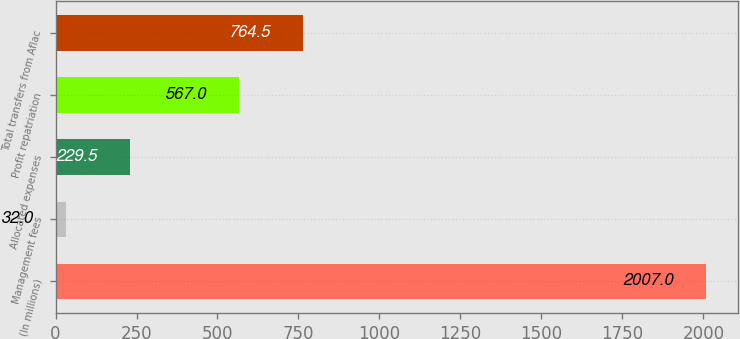Convert chart. <chart><loc_0><loc_0><loc_500><loc_500><bar_chart><fcel>(In millions)<fcel>Management fees<fcel>Allocated expenses<fcel>Profit repatriation<fcel>Total transfers from Aflac<nl><fcel>2007<fcel>32<fcel>229.5<fcel>567<fcel>764.5<nl></chart> 